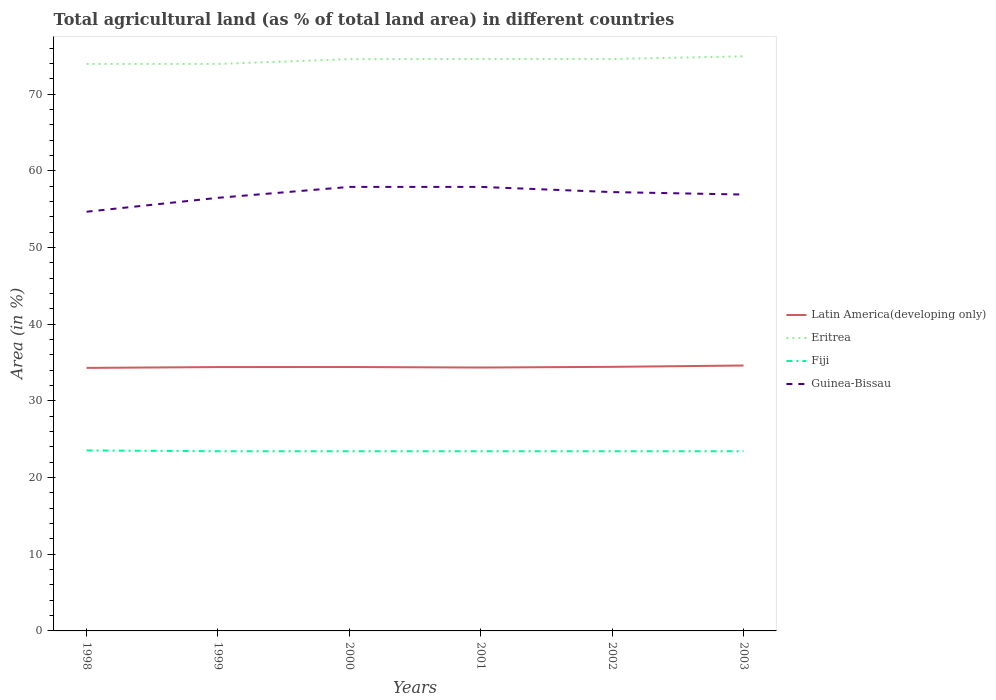How many different coloured lines are there?
Your answer should be very brief. 4. Does the line corresponding to Fiji intersect with the line corresponding to Latin America(developing only)?
Your answer should be very brief. No. Is the number of lines equal to the number of legend labels?
Provide a short and direct response. Yes. Across all years, what is the maximum percentage of agricultural land in Latin America(developing only)?
Your answer should be very brief. 34.3. In which year was the percentage of agricultural land in Guinea-Bissau maximum?
Offer a terse response. 1998. What is the total percentage of agricultural land in Fiji in the graph?
Offer a terse response. 0.11. What is the difference between the highest and the second highest percentage of agricultural land in Latin America(developing only)?
Keep it short and to the point. 0.31. How many years are there in the graph?
Offer a terse response. 6. What is the difference between two consecutive major ticks on the Y-axis?
Your answer should be very brief. 10. Does the graph contain grids?
Provide a succinct answer. No. Where does the legend appear in the graph?
Keep it short and to the point. Center right. How many legend labels are there?
Your answer should be compact. 4. How are the legend labels stacked?
Offer a terse response. Vertical. What is the title of the graph?
Offer a very short reply. Total agricultural land (as % of total land area) in different countries. What is the label or title of the X-axis?
Provide a succinct answer. Years. What is the label or title of the Y-axis?
Provide a succinct answer. Area (in %). What is the Area (in %) in Latin America(developing only) in 1998?
Make the answer very short. 34.3. What is the Area (in %) of Eritrea in 1998?
Provide a short and direct response. 73.93. What is the Area (in %) in Fiji in 1998?
Ensure brevity in your answer.  23.54. What is the Area (in %) in Guinea-Bissau in 1998?
Keep it short and to the point. 54.66. What is the Area (in %) in Latin America(developing only) in 1999?
Offer a terse response. 34.4. What is the Area (in %) of Eritrea in 1999?
Ensure brevity in your answer.  73.93. What is the Area (in %) of Fiji in 1999?
Your answer should be compact. 23.43. What is the Area (in %) of Guinea-Bissau in 1999?
Offer a very short reply. 56.47. What is the Area (in %) in Latin America(developing only) in 2000?
Offer a very short reply. 34.41. What is the Area (in %) of Eritrea in 2000?
Make the answer very short. 74.55. What is the Area (in %) of Fiji in 2000?
Provide a succinct answer. 23.43. What is the Area (in %) of Guinea-Bissau in 2000?
Provide a short and direct response. 57.89. What is the Area (in %) in Latin America(developing only) in 2001?
Your answer should be compact. 34.34. What is the Area (in %) of Eritrea in 2001?
Offer a very short reply. 74.57. What is the Area (in %) of Fiji in 2001?
Provide a short and direct response. 23.43. What is the Area (in %) of Guinea-Bissau in 2001?
Keep it short and to the point. 57.89. What is the Area (in %) of Latin America(developing only) in 2002?
Offer a very short reply. 34.43. What is the Area (in %) in Eritrea in 2002?
Give a very brief answer. 74.57. What is the Area (in %) in Fiji in 2002?
Ensure brevity in your answer.  23.43. What is the Area (in %) in Guinea-Bissau in 2002?
Give a very brief answer. 57.22. What is the Area (in %) of Latin America(developing only) in 2003?
Your response must be concise. 34.61. What is the Area (in %) in Eritrea in 2003?
Provide a succinct answer. 74.92. What is the Area (in %) of Fiji in 2003?
Make the answer very short. 23.43. What is the Area (in %) of Guinea-Bissau in 2003?
Give a very brief answer. 56.9. Across all years, what is the maximum Area (in %) of Latin America(developing only)?
Offer a terse response. 34.61. Across all years, what is the maximum Area (in %) of Eritrea?
Give a very brief answer. 74.92. Across all years, what is the maximum Area (in %) in Fiji?
Keep it short and to the point. 23.54. Across all years, what is the maximum Area (in %) in Guinea-Bissau?
Provide a short and direct response. 57.89. Across all years, what is the minimum Area (in %) of Latin America(developing only)?
Your answer should be compact. 34.3. Across all years, what is the minimum Area (in %) of Eritrea?
Keep it short and to the point. 73.93. Across all years, what is the minimum Area (in %) of Fiji?
Provide a succinct answer. 23.43. Across all years, what is the minimum Area (in %) in Guinea-Bissau?
Your response must be concise. 54.66. What is the total Area (in %) in Latin America(developing only) in the graph?
Your answer should be compact. 206.49. What is the total Area (in %) of Eritrea in the graph?
Your answer should be compact. 446.49. What is the total Area (in %) in Fiji in the graph?
Keep it short and to the point. 140.67. What is the total Area (in %) of Guinea-Bissau in the graph?
Your answer should be compact. 341.04. What is the difference between the Area (in %) of Latin America(developing only) in 1998 and that in 1999?
Ensure brevity in your answer.  -0.11. What is the difference between the Area (in %) in Eritrea in 1998 and that in 1999?
Provide a short and direct response. 0. What is the difference between the Area (in %) in Fiji in 1998 and that in 1999?
Offer a very short reply. 0.11. What is the difference between the Area (in %) of Guinea-Bissau in 1998 and that in 1999?
Ensure brevity in your answer.  -1.81. What is the difference between the Area (in %) in Latin America(developing only) in 1998 and that in 2000?
Your response must be concise. -0.11. What is the difference between the Area (in %) of Eritrea in 1998 and that in 2000?
Give a very brief answer. -0.62. What is the difference between the Area (in %) of Fiji in 1998 and that in 2000?
Offer a terse response. 0.11. What is the difference between the Area (in %) in Guinea-Bissau in 1998 and that in 2000?
Make the answer very short. -3.24. What is the difference between the Area (in %) in Latin America(developing only) in 1998 and that in 2001?
Give a very brief answer. -0.05. What is the difference between the Area (in %) in Eritrea in 1998 and that in 2001?
Offer a very short reply. -0.64. What is the difference between the Area (in %) in Fiji in 1998 and that in 2001?
Make the answer very short. 0.11. What is the difference between the Area (in %) of Guinea-Bissau in 1998 and that in 2001?
Your answer should be very brief. -3.24. What is the difference between the Area (in %) of Latin America(developing only) in 1998 and that in 2002?
Your response must be concise. -0.14. What is the difference between the Area (in %) of Eritrea in 1998 and that in 2002?
Ensure brevity in your answer.  -0.64. What is the difference between the Area (in %) in Fiji in 1998 and that in 2002?
Ensure brevity in your answer.  0.11. What is the difference between the Area (in %) in Guinea-Bissau in 1998 and that in 2002?
Give a very brief answer. -2.56. What is the difference between the Area (in %) in Latin America(developing only) in 1998 and that in 2003?
Offer a very short reply. -0.31. What is the difference between the Area (in %) of Eritrea in 1998 and that in 2003?
Keep it short and to the point. -0.99. What is the difference between the Area (in %) of Fiji in 1998 and that in 2003?
Keep it short and to the point. 0.11. What is the difference between the Area (in %) in Guinea-Bissau in 1998 and that in 2003?
Make the answer very short. -2.24. What is the difference between the Area (in %) of Latin America(developing only) in 1999 and that in 2000?
Offer a very short reply. -0.01. What is the difference between the Area (in %) in Eritrea in 1999 and that in 2000?
Your answer should be compact. -0.62. What is the difference between the Area (in %) of Fiji in 1999 and that in 2000?
Keep it short and to the point. 0. What is the difference between the Area (in %) in Guinea-Bissau in 1999 and that in 2000?
Keep it short and to the point. -1.42. What is the difference between the Area (in %) in Latin America(developing only) in 1999 and that in 2001?
Offer a very short reply. 0.06. What is the difference between the Area (in %) of Eritrea in 1999 and that in 2001?
Make the answer very short. -0.64. What is the difference between the Area (in %) in Guinea-Bissau in 1999 and that in 2001?
Keep it short and to the point. -1.42. What is the difference between the Area (in %) of Latin America(developing only) in 1999 and that in 2002?
Make the answer very short. -0.03. What is the difference between the Area (in %) of Eritrea in 1999 and that in 2002?
Offer a very short reply. -0.64. What is the difference between the Area (in %) of Guinea-Bissau in 1999 and that in 2002?
Make the answer very short. -0.75. What is the difference between the Area (in %) in Latin America(developing only) in 1999 and that in 2003?
Provide a short and direct response. -0.2. What is the difference between the Area (in %) in Eritrea in 1999 and that in 2003?
Your response must be concise. -0.99. What is the difference between the Area (in %) in Fiji in 1999 and that in 2003?
Provide a short and direct response. 0. What is the difference between the Area (in %) of Guinea-Bissau in 1999 and that in 2003?
Provide a short and direct response. -0.43. What is the difference between the Area (in %) of Latin America(developing only) in 2000 and that in 2001?
Provide a succinct answer. 0.07. What is the difference between the Area (in %) in Eritrea in 2000 and that in 2001?
Your answer should be compact. -0.02. What is the difference between the Area (in %) of Fiji in 2000 and that in 2001?
Provide a succinct answer. 0. What is the difference between the Area (in %) in Guinea-Bissau in 2000 and that in 2001?
Ensure brevity in your answer.  0. What is the difference between the Area (in %) of Latin America(developing only) in 2000 and that in 2002?
Keep it short and to the point. -0.02. What is the difference between the Area (in %) of Eritrea in 2000 and that in 2002?
Your answer should be very brief. -0.02. What is the difference between the Area (in %) in Guinea-Bissau in 2000 and that in 2002?
Your response must be concise. 0.68. What is the difference between the Area (in %) of Latin America(developing only) in 2000 and that in 2003?
Provide a short and direct response. -0.19. What is the difference between the Area (in %) in Eritrea in 2000 and that in 2003?
Keep it short and to the point. -0.37. What is the difference between the Area (in %) of Latin America(developing only) in 2001 and that in 2002?
Keep it short and to the point. -0.09. What is the difference between the Area (in %) in Guinea-Bissau in 2001 and that in 2002?
Offer a very short reply. 0.68. What is the difference between the Area (in %) in Latin America(developing only) in 2001 and that in 2003?
Ensure brevity in your answer.  -0.26. What is the difference between the Area (in %) of Eritrea in 2001 and that in 2003?
Offer a very short reply. -0.35. What is the difference between the Area (in %) of Latin America(developing only) in 2002 and that in 2003?
Make the answer very short. -0.17. What is the difference between the Area (in %) in Eritrea in 2002 and that in 2003?
Ensure brevity in your answer.  -0.35. What is the difference between the Area (in %) of Fiji in 2002 and that in 2003?
Your answer should be very brief. 0. What is the difference between the Area (in %) of Guinea-Bissau in 2002 and that in 2003?
Give a very brief answer. 0.32. What is the difference between the Area (in %) in Latin America(developing only) in 1998 and the Area (in %) in Eritrea in 1999?
Keep it short and to the point. -39.63. What is the difference between the Area (in %) in Latin America(developing only) in 1998 and the Area (in %) in Fiji in 1999?
Your answer should be compact. 10.87. What is the difference between the Area (in %) in Latin America(developing only) in 1998 and the Area (in %) in Guinea-Bissau in 1999?
Ensure brevity in your answer.  -22.18. What is the difference between the Area (in %) of Eritrea in 1998 and the Area (in %) of Fiji in 1999?
Ensure brevity in your answer.  50.5. What is the difference between the Area (in %) of Eritrea in 1998 and the Area (in %) of Guinea-Bissau in 1999?
Your response must be concise. 17.46. What is the difference between the Area (in %) of Fiji in 1998 and the Area (in %) of Guinea-Bissau in 1999?
Keep it short and to the point. -32.94. What is the difference between the Area (in %) in Latin America(developing only) in 1998 and the Area (in %) in Eritrea in 2000?
Make the answer very short. -40.26. What is the difference between the Area (in %) of Latin America(developing only) in 1998 and the Area (in %) of Fiji in 2000?
Ensure brevity in your answer.  10.87. What is the difference between the Area (in %) in Latin America(developing only) in 1998 and the Area (in %) in Guinea-Bissau in 2000?
Ensure brevity in your answer.  -23.6. What is the difference between the Area (in %) in Eritrea in 1998 and the Area (in %) in Fiji in 2000?
Your response must be concise. 50.5. What is the difference between the Area (in %) of Eritrea in 1998 and the Area (in %) of Guinea-Bissau in 2000?
Your answer should be very brief. 16.04. What is the difference between the Area (in %) in Fiji in 1998 and the Area (in %) in Guinea-Bissau in 2000?
Your answer should be very brief. -34.36. What is the difference between the Area (in %) in Latin America(developing only) in 1998 and the Area (in %) in Eritrea in 2001?
Provide a succinct answer. -40.28. What is the difference between the Area (in %) of Latin America(developing only) in 1998 and the Area (in %) of Fiji in 2001?
Provide a short and direct response. 10.87. What is the difference between the Area (in %) of Latin America(developing only) in 1998 and the Area (in %) of Guinea-Bissau in 2001?
Ensure brevity in your answer.  -23.6. What is the difference between the Area (in %) in Eritrea in 1998 and the Area (in %) in Fiji in 2001?
Offer a very short reply. 50.5. What is the difference between the Area (in %) of Eritrea in 1998 and the Area (in %) of Guinea-Bissau in 2001?
Your answer should be very brief. 16.04. What is the difference between the Area (in %) of Fiji in 1998 and the Area (in %) of Guinea-Bissau in 2001?
Your response must be concise. -34.36. What is the difference between the Area (in %) of Latin America(developing only) in 1998 and the Area (in %) of Eritrea in 2002?
Provide a short and direct response. -40.28. What is the difference between the Area (in %) of Latin America(developing only) in 1998 and the Area (in %) of Fiji in 2002?
Make the answer very short. 10.87. What is the difference between the Area (in %) in Latin America(developing only) in 1998 and the Area (in %) in Guinea-Bissau in 2002?
Your response must be concise. -22.92. What is the difference between the Area (in %) of Eritrea in 1998 and the Area (in %) of Fiji in 2002?
Offer a very short reply. 50.5. What is the difference between the Area (in %) in Eritrea in 1998 and the Area (in %) in Guinea-Bissau in 2002?
Keep it short and to the point. 16.71. What is the difference between the Area (in %) of Fiji in 1998 and the Area (in %) of Guinea-Bissau in 2002?
Keep it short and to the point. -33.68. What is the difference between the Area (in %) in Latin America(developing only) in 1998 and the Area (in %) in Eritrea in 2003?
Your answer should be compact. -40.62. What is the difference between the Area (in %) of Latin America(developing only) in 1998 and the Area (in %) of Fiji in 2003?
Give a very brief answer. 10.87. What is the difference between the Area (in %) of Latin America(developing only) in 1998 and the Area (in %) of Guinea-Bissau in 2003?
Ensure brevity in your answer.  -22.6. What is the difference between the Area (in %) in Eritrea in 1998 and the Area (in %) in Fiji in 2003?
Ensure brevity in your answer.  50.5. What is the difference between the Area (in %) in Eritrea in 1998 and the Area (in %) in Guinea-Bissau in 2003?
Make the answer very short. 17.03. What is the difference between the Area (in %) of Fiji in 1998 and the Area (in %) of Guinea-Bissau in 2003?
Your answer should be compact. -33.36. What is the difference between the Area (in %) of Latin America(developing only) in 1999 and the Area (in %) of Eritrea in 2000?
Ensure brevity in your answer.  -40.15. What is the difference between the Area (in %) in Latin America(developing only) in 1999 and the Area (in %) in Fiji in 2000?
Your answer should be compact. 10.97. What is the difference between the Area (in %) in Latin America(developing only) in 1999 and the Area (in %) in Guinea-Bissau in 2000?
Offer a terse response. -23.49. What is the difference between the Area (in %) of Eritrea in 1999 and the Area (in %) of Fiji in 2000?
Make the answer very short. 50.5. What is the difference between the Area (in %) of Eritrea in 1999 and the Area (in %) of Guinea-Bissau in 2000?
Keep it short and to the point. 16.04. What is the difference between the Area (in %) of Fiji in 1999 and the Area (in %) of Guinea-Bissau in 2000?
Your answer should be compact. -34.47. What is the difference between the Area (in %) in Latin America(developing only) in 1999 and the Area (in %) in Eritrea in 2001?
Give a very brief answer. -40.17. What is the difference between the Area (in %) in Latin America(developing only) in 1999 and the Area (in %) in Fiji in 2001?
Offer a terse response. 10.97. What is the difference between the Area (in %) of Latin America(developing only) in 1999 and the Area (in %) of Guinea-Bissau in 2001?
Your answer should be compact. -23.49. What is the difference between the Area (in %) of Eritrea in 1999 and the Area (in %) of Fiji in 2001?
Your response must be concise. 50.5. What is the difference between the Area (in %) of Eritrea in 1999 and the Area (in %) of Guinea-Bissau in 2001?
Offer a terse response. 16.04. What is the difference between the Area (in %) in Fiji in 1999 and the Area (in %) in Guinea-Bissau in 2001?
Offer a very short reply. -34.47. What is the difference between the Area (in %) of Latin America(developing only) in 1999 and the Area (in %) of Eritrea in 2002?
Offer a very short reply. -40.17. What is the difference between the Area (in %) in Latin America(developing only) in 1999 and the Area (in %) in Fiji in 2002?
Offer a very short reply. 10.97. What is the difference between the Area (in %) of Latin America(developing only) in 1999 and the Area (in %) of Guinea-Bissau in 2002?
Provide a short and direct response. -22.82. What is the difference between the Area (in %) of Eritrea in 1999 and the Area (in %) of Fiji in 2002?
Give a very brief answer. 50.5. What is the difference between the Area (in %) in Eritrea in 1999 and the Area (in %) in Guinea-Bissau in 2002?
Your answer should be very brief. 16.71. What is the difference between the Area (in %) in Fiji in 1999 and the Area (in %) in Guinea-Bissau in 2002?
Keep it short and to the point. -33.79. What is the difference between the Area (in %) of Latin America(developing only) in 1999 and the Area (in %) of Eritrea in 2003?
Your response must be concise. -40.52. What is the difference between the Area (in %) in Latin America(developing only) in 1999 and the Area (in %) in Fiji in 2003?
Offer a terse response. 10.97. What is the difference between the Area (in %) in Latin America(developing only) in 1999 and the Area (in %) in Guinea-Bissau in 2003?
Provide a short and direct response. -22.5. What is the difference between the Area (in %) of Eritrea in 1999 and the Area (in %) of Fiji in 2003?
Provide a succinct answer. 50.5. What is the difference between the Area (in %) of Eritrea in 1999 and the Area (in %) of Guinea-Bissau in 2003?
Your answer should be compact. 17.03. What is the difference between the Area (in %) in Fiji in 1999 and the Area (in %) in Guinea-Bissau in 2003?
Offer a very short reply. -33.47. What is the difference between the Area (in %) in Latin America(developing only) in 2000 and the Area (in %) in Eritrea in 2001?
Your answer should be compact. -40.16. What is the difference between the Area (in %) of Latin America(developing only) in 2000 and the Area (in %) of Fiji in 2001?
Provide a short and direct response. 10.98. What is the difference between the Area (in %) of Latin America(developing only) in 2000 and the Area (in %) of Guinea-Bissau in 2001?
Your response must be concise. -23.48. What is the difference between the Area (in %) of Eritrea in 2000 and the Area (in %) of Fiji in 2001?
Offer a terse response. 51.13. What is the difference between the Area (in %) of Eritrea in 2000 and the Area (in %) of Guinea-Bissau in 2001?
Keep it short and to the point. 16.66. What is the difference between the Area (in %) of Fiji in 2000 and the Area (in %) of Guinea-Bissau in 2001?
Make the answer very short. -34.47. What is the difference between the Area (in %) in Latin America(developing only) in 2000 and the Area (in %) in Eritrea in 2002?
Your response must be concise. -40.16. What is the difference between the Area (in %) of Latin America(developing only) in 2000 and the Area (in %) of Fiji in 2002?
Ensure brevity in your answer.  10.98. What is the difference between the Area (in %) of Latin America(developing only) in 2000 and the Area (in %) of Guinea-Bissau in 2002?
Provide a succinct answer. -22.81. What is the difference between the Area (in %) in Eritrea in 2000 and the Area (in %) in Fiji in 2002?
Make the answer very short. 51.13. What is the difference between the Area (in %) in Eritrea in 2000 and the Area (in %) in Guinea-Bissau in 2002?
Provide a short and direct response. 17.34. What is the difference between the Area (in %) in Fiji in 2000 and the Area (in %) in Guinea-Bissau in 2002?
Your response must be concise. -33.79. What is the difference between the Area (in %) of Latin America(developing only) in 2000 and the Area (in %) of Eritrea in 2003?
Keep it short and to the point. -40.51. What is the difference between the Area (in %) of Latin America(developing only) in 2000 and the Area (in %) of Fiji in 2003?
Your answer should be very brief. 10.98. What is the difference between the Area (in %) of Latin America(developing only) in 2000 and the Area (in %) of Guinea-Bissau in 2003?
Provide a succinct answer. -22.49. What is the difference between the Area (in %) of Eritrea in 2000 and the Area (in %) of Fiji in 2003?
Your answer should be very brief. 51.13. What is the difference between the Area (in %) of Eritrea in 2000 and the Area (in %) of Guinea-Bissau in 2003?
Ensure brevity in your answer.  17.66. What is the difference between the Area (in %) in Fiji in 2000 and the Area (in %) in Guinea-Bissau in 2003?
Make the answer very short. -33.47. What is the difference between the Area (in %) of Latin America(developing only) in 2001 and the Area (in %) of Eritrea in 2002?
Offer a terse response. -40.23. What is the difference between the Area (in %) in Latin America(developing only) in 2001 and the Area (in %) in Fiji in 2002?
Your answer should be very brief. 10.92. What is the difference between the Area (in %) of Latin America(developing only) in 2001 and the Area (in %) of Guinea-Bissau in 2002?
Provide a short and direct response. -22.88. What is the difference between the Area (in %) of Eritrea in 2001 and the Area (in %) of Fiji in 2002?
Ensure brevity in your answer.  51.15. What is the difference between the Area (in %) of Eritrea in 2001 and the Area (in %) of Guinea-Bissau in 2002?
Keep it short and to the point. 17.36. What is the difference between the Area (in %) of Fiji in 2001 and the Area (in %) of Guinea-Bissau in 2002?
Provide a succinct answer. -33.79. What is the difference between the Area (in %) in Latin America(developing only) in 2001 and the Area (in %) in Eritrea in 2003?
Ensure brevity in your answer.  -40.58. What is the difference between the Area (in %) of Latin America(developing only) in 2001 and the Area (in %) of Fiji in 2003?
Your answer should be compact. 10.92. What is the difference between the Area (in %) in Latin America(developing only) in 2001 and the Area (in %) in Guinea-Bissau in 2003?
Your response must be concise. -22.56. What is the difference between the Area (in %) in Eritrea in 2001 and the Area (in %) in Fiji in 2003?
Give a very brief answer. 51.15. What is the difference between the Area (in %) in Eritrea in 2001 and the Area (in %) in Guinea-Bissau in 2003?
Provide a succinct answer. 17.68. What is the difference between the Area (in %) in Fiji in 2001 and the Area (in %) in Guinea-Bissau in 2003?
Your response must be concise. -33.47. What is the difference between the Area (in %) in Latin America(developing only) in 2002 and the Area (in %) in Eritrea in 2003?
Offer a very short reply. -40.49. What is the difference between the Area (in %) of Latin America(developing only) in 2002 and the Area (in %) of Fiji in 2003?
Offer a terse response. 11.01. What is the difference between the Area (in %) of Latin America(developing only) in 2002 and the Area (in %) of Guinea-Bissau in 2003?
Provide a succinct answer. -22.47. What is the difference between the Area (in %) of Eritrea in 2002 and the Area (in %) of Fiji in 2003?
Provide a succinct answer. 51.15. What is the difference between the Area (in %) of Eritrea in 2002 and the Area (in %) of Guinea-Bissau in 2003?
Ensure brevity in your answer.  17.68. What is the difference between the Area (in %) in Fiji in 2002 and the Area (in %) in Guinea-Bissau in 2003?
Your answer should be compact. -33.47. What is the average Area (in %) of Latin America(developing only) per year?
Make the answer very short. 34.41. What is the average Area (in %) of Eritrea per year?
Provide a succinct answer. 74.41. What is the average Area (in %) in Fiji per year?
Offer a very short reply. 23.44. What is the average Area (in %) in Guinea-Bissau per year?
Your answer should be compact. 56.84. In the year 1998, what is the difference between the Area (in %) in Latin America(developing only) and Area (in %) in Eritrea?
Provide a short and direct response. -39.63. In the year 1998, what is the difference between the Area (in %) of Latin America(developing only) and Area (in %) of Fiji?
Provide a succinct answer. 10.76. In the year 1998, what is the difference between the Area (in %) of Latin America(developing only) and Area (in %) of Guinea-Bissau?
Your answer should be compact. -20.36. In the year 1998, what is the difference between the Area (in %) of Eritrea and Area (in %) of Fiji?
Ensure brevity in your answer.  50.39. In the year 1998, what is the difference between the Area (in %) of Eritrea and Area (in %) of Guinea-Bissau?
Keep it short and to the point. 19.27. In the year 1998, what is the difference between the Area (in %) in Fiji and Area (in %) in Guinea-Bissau?
Keep it short and to the point. -31.12. In the year 1999, what is the difference between the Area (in %) in Latin America(developing only) and Area (in %) in Eritrea?
Your answer should be very brief. -39.53. In the year 1999, what is the difference between the Area (in %) in Latin America(developing only) and Area (in %) in Fiji?
Your response must be concise. 10.97. In the year 1999, what is the difference between the Area (in %) of Latin America(developing only) and Area (in %) of Guinea-Bissau?
Make the answer very short. -22.07. In the year 1999, what is the difference between the Area (in %) in Eritrea and Area (in %) in Fiji?
Give a very brief answer. 50.5. In the year 1999, what is the difference between the Area (in %) of Eritrea and Area (in %) of Guinea-Bissau?
Your answer should be very brief. 17.46. In the year 1999, what is the difference between the Area (in %) of Fiji and Area (in %) of Guinea-Bissau?
Your answer should be very brief. -33.05. In the year 2000, what is the difference between the Area (in %) of Latin America(developing only) and Area (in %) of Eritrea?
Provide a short and direct response. -40.14. In the year 2000, what is the difference between the Area (in %) of Latin America(developing only) and Area (in %) of Fiji?
Offer a terse response. 10.98. In the year 2000, what is the difference between the Area (in %) of Latin America(developing only) and Area (in %) of Guinea-Bissau?
Make the answer very short. -23.48. In the year 2000, what is the difference between the Area (in %) of Eritrea and Area (in %) of Fiji?
Your answer should be very brief. 51.13. In the year 2000, what is the difference between the Area (in %) in Eritrea and Area (in %) in Guinea-Bissau?
Offer a terse response. 16.66. In the year 2000, what is the difference between the Area (in %) in Fiji and Area (in %) in Guinea-Bissau?
Make the answer very short. -34.47. In the year 2001, what is the difference between the Area (in %) in Latin America(developing only) and Area (in %) in Eritrea?
Provide a short and direct response. -40.23. In the year 2001, what is the difference between the Area (in %) of Latin America(developing only) and Area (in %) of Fiji?
Give a very brief answer. 10.92. In the year 2001, what is the difference between the Area (in %) of Latin America(developing only) and Area (in %) of Guinea-Bissau?
Provide a short and direct response. -23.55. In the year 2001, what is the difference between the Area (in %) in Eritrea and Area (in %) in Fiji?
Ensure brevity in your answer.  51.15. In the year 2001, what is the difference between the Area (in %) in Eritrea and Area (in %) in Guinea-Bissau?
Your answer should be compact. 16.68. In the year 2001, what is the difference between the Area (in %) in Fiji and Area (in %) in Guinea-Bissau?
Provide a succinct answer. -34.47. In the year 2002, what is the difference between the Area (in %) in Latin America(developing only) and Area (in %) in Eritrea?
Keep it short and to the point. -40.14. In the year 2002, what is the difference between the Area (in %) in Latin America(developing only) and Area (in %) in Fiji?
Provide a succinct answer. 11.01. In the year 2002, what is the difference between the Area (in %) in Latin America(developing only) and Area (in %) in Guinea-Bissau?
Your answer should be compact. -22.79. In the year 2002, what is the difference between the Area (in %) in Eritrea and Area (in %) in Fiji?
Offer a terse response. 51.15. In the year 2002, what is the difference between the Area (in %) in Eritrea and Area (in %) in Guinea-Bissau?
Ensure brevity in your answer.  17.36. In the year 2002, what is the difference between the Area (in %) in Fiji and Area (in %) in Guinea-Bissau?
Make the answer very short. -33.79. In the year 2003, what is the difference between the Area (in %) in Latin America(developing only) and Area (in %) in Eritrea?
Your answer should be very brief. -40.32. In the year 2003, what is the difference between the Area (in %) in Latin America(developing only) and Area (in %) in Fiji?
Offer a very short reply. 11.18. In the year 2003, what is the difference between the Area (in %) of Latin America(developing only) and Area (in %) of Guinea-Bissau?
Your answer should be compact. -22.29. In the year 2003, what is the difference between the Area (in %) in Eritrea and Area (in %) in Fiji?
Give a very brief answer. 51.49. In the year 2003, what is the difference between the Area (in %) of Eritrea and Area (in %) of Guinea-Bissau?
Give a very brief answer. 18.02. In the year 2003, what is the difference between the Area (in %) in Fiji and Area (in %) in Guinea-Bissau?
Provide a short and direct response. -33.47. What is the ratio of the Area (in %) in Latin America(developing only) in 1998 to that in 1999?
Make the answer very short. 1. What is the ratio of the Area (in %) of Eritrea in 1998 to that in 1999?
Offer a very short reply. 1. What is the ratio of the Area (in %) of Fiji in 1998 to that in 1999?
Keep it short and to the point. 1. What is the ratio of the Area (in %) in Guinea-Bissau in 1998 to that in 1999?
Give a very brief answer. 0.97. What is the ratio of the Area (in %) of Eritrea in 1998 to that in 2000?
Your answer should be very brief. 0.99. What is the ratio of the Area (in %) of Guinea-Bissau in 1998 to that in 2000?
Your response must be concise. 0.94. What is the ratio of the Area (in %) of Eritrea in 1998 to that in 2001?
Your answer should be compact. 0.99. What is the ratio of the Area (in %) in Fiji in 1998 to that in 2001?
Your response must be concise. 1. What is the ratio of the Area (in %) of Guinea-Bissau in 1998 to that in 2001?
Offer a terse response. 0.94. What is the ratio of the Area (in %) of Latin America(developing only) in 1998 to that in 2002?
Offer a terse response. 1. What is the ratio of the Area (in %) in Fiji in 1998 to that in 2002?
Offer a very short reply. 1. What is the ratio of the Area (in %) of Guinea-Bissau in 1998 to that in 2002?
Ensure brevity in your answer.  0.96. What is the ratio of the Area (in %) in Latin America(developing only) in 1998 to that in 2003?
Provide a succinct answer. 0.99. What is the ratio of the Area (in %) of Guinea-Bissau in 1998 to that in 2003?
Your answer should be very brief. 0.96. What is the ratio of the Area (in %) of Latin America(developing only) in 1999 to that in 2000?
Offer a terse response. 1. What is the ratio of the Area (in %) in Eritrea in 1999 to that in 2000?
Offer a terse response. 0.99. What is the ratio of the Area (in %) in Fiji in 1999 to that in 2000?
Ensure brevity in your answer.  1. What is the ratio of the Area (in %) of Guinea-Bissau in 1999 to that in 2000?
Provide a short and direct response. 0.98. What is the ratio of the Area (in %) in Latin America(developing only) in 1999 to that in 2001?
Provide a succinct answer. 1. What is the ratio of the Area (in %) in Eritrea in 1999 to that in 2001?
Ensure brevity in your answer.  0.99. What is the ratio of the Area (in %) in Guinea-Bissau in 1999 to that in 2001?
Your answer should be compact. 0.98. What is the ratio of the Area (in %) in Guinea-Bissau in 1999 to that in 2002?
Keep it short and to the point. 0.99. What is the ratio of the Area (in %) in Eritrea in 1999 to that in 2003?
Make the answer very short. 0.99. What is the ratio of the Area (in %) of Guinea-Bissau in 1999 to that in 2003?
Your answer should be very brief. 0.99. What is the ratio of the Area (in %) of Latin America(developing only) in 2000 to that in 2001?
Offer a terse response. 1. What is the ratio of the Area (in %) in Fiji in 2000 to that in 2001?
Provide a short and direct response. 1. What is the ratio of the Area (in %) in Guinea-Bissau in 2000 to that in 2001?
Your answer should be compact. 1. What is the ratio of the Area (in %) of Eritrea in 2000 to that in 2002?
Offer a terse response. 1. What is the ratio of the Area (in %) of Guinea-Bissau in 2000 to that in 2002?
Your answer should be compact. 1.01. What is the ratio of the Area (in %) of Latin America(developing only) in 2000 to that in 2003?
Provide a succinct answer. 0.99. What is the ratio of the Area (in %) of Eritrea in 2000 to that in 2003?
Ensure brevity in your answer.  1. What is the ratio of the Area (in %) in Guinea-Bissau in 2000 to that in 2003?
Your answer should be compact. 1.02. What is the ratio of the Area (in %) in Latin America(developing only) in 2001 to that in 2002?
Provide a succinct answer. 1. What is the ratio of the Area (in %) of Fiji in 2001 to that in 2002?
Give a very brief answer. 1. What is the ratio of the Area (in %) of Guinea-Bissau in 2001 to that in 2002?
Offer a very short reply. 1.01. What is the ratio of the Area (in %) in Eritrea in 2001 to that in 2003?
Give a very brief answer. 1. What is the ratio of the Area (in %) in Fiji in 2001 to that in 2003?
Keep it short and to the point. 1. What is the ratio of the Area (in %) of Guinea-Bissau in 2001 to that in 2003?
Your answer should be compact. 1.02. What is the ratio of the Area (in %) in Latin America(developing only) in 2002 to that in 2003?
Keep it short and to the point. 0.99. What is the ratio of the Area (in %) of Guinea-Bissau in 2002 to that in 2003?
Offer a very short reply. 1.01. What is the difference between the highest and the second highest Area (in %) of Latin America(developing only)?
Your answer should be compact. 0.17. What is the difference between the highest and the second highest Area (in %) of Eritrea?
Your response must be concise. 0.35. What is the difference between the highest and the second highest Area (in %) of Fiji?
Keep it short and to the point. 0.11. What is the difference between the highest and the second highest Area (in %) of Guinea-Bissau?
Make the answer very short. 0. What is the difference between the highest and the lowest Area (in %) in Latin America(developing only)?
Ensure brevity in your answer.  0.31. What is the difference between the highest and the lowest Area (in %) of Fiji?
Ensure brevity in your answer.  0.11. What is the difference between the highest and the lowest Area (in %) of Guinea-Bissau?
Provide a succinct answer. 3.24. 